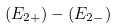Convert formula to latex. <formula><loc_0><loc_0><loc_500><loc_500>( E _ { 2 + } ) - ( E _ { 2 - } )</formula> 